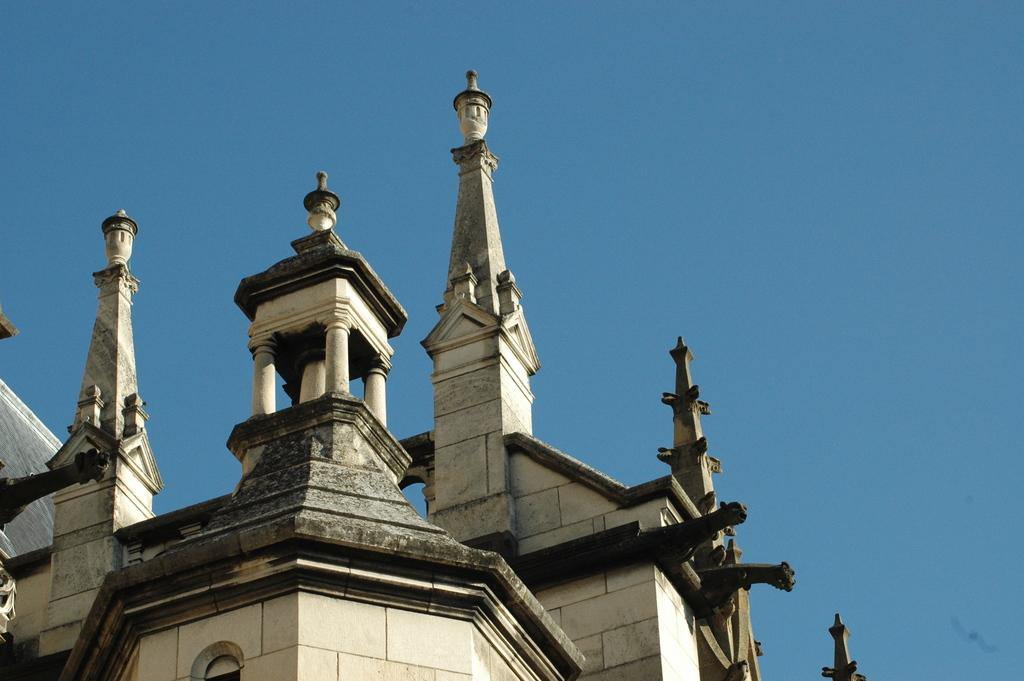What type of architecture can be seen in the image? There is an architecture (building or structure) in the image, but the specific type cannot be determined without more information. Can you describe any unique features of the architecture in the image? Without more information, it is difficult to describe any unique features of the architecture in the image. Is the architecture in the image old or new? The age of the architecture in the image cannot be determined without more information. How many bears are visible in the image? There are no bears present in the image. What is the amount of water in the image? The amount of water in the image cannot be determined without more information. 